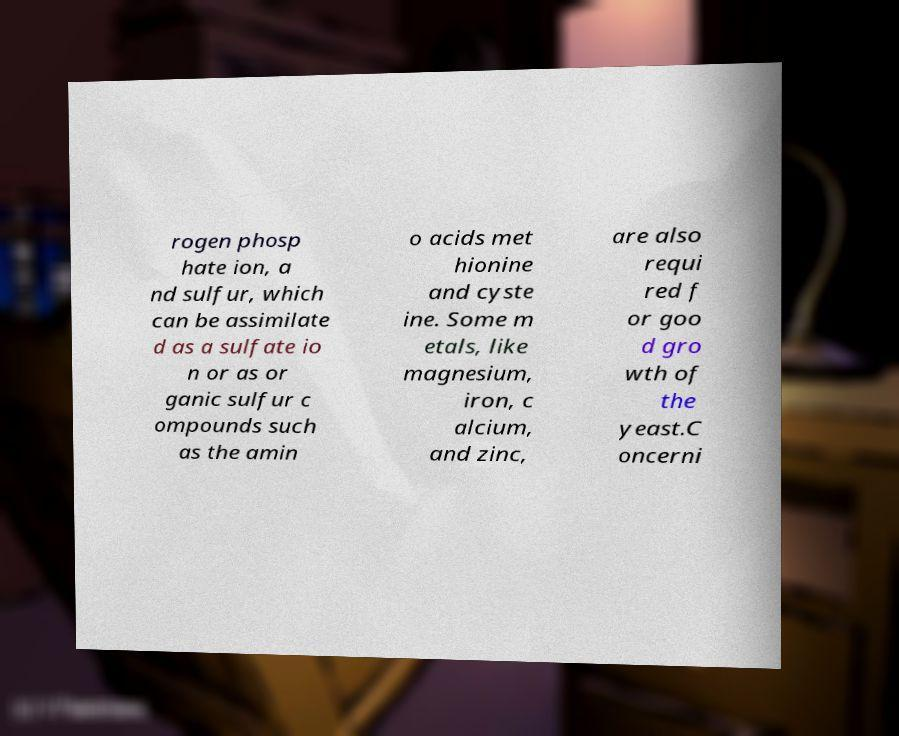What messages or text are displayed in this image? I need them in a readable, typed format. rogen phosp hate ion, a nd sulfur, which can be assimilate d as a sulfate io n or as or ganic sulfur c ompounds such as the amin o acids met hionine and cyste ine. Some m etals, like magnesium, iron, c alcium, and zinc, are also requi red f or goo d gro wth of the yeast.C oncerni 